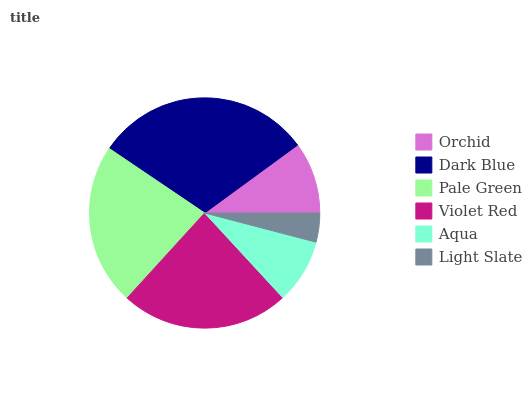Is Light Slate the minimum?
Answer yes or no. Yes. Is Dark Blue the maximum?
Answer yes or no. Yes. Is Pale Green the minimum?
Answer yes or no. No. Is Pale Green the maximum?
Answer yes or no. No. Is Dark Blue greater than Pale Green?
Answer yes or no. Yes. Is Pale Green less than Dark Blue?
Answer yes or no. Yes. Is Pale Green greater than Dark Blue?
Answer yes or no. No. Is Dark Blue less than Pale Green?
Answer yes or no. No. Is Pale Green the high median?
Answer yes or no. Yes. Is Orchid the low median?
Answer yes or no. Yes. Is Violet Red the high median?
Answer yes or no. No. Is Violet Red the low median?
Answer yes or no. No. 